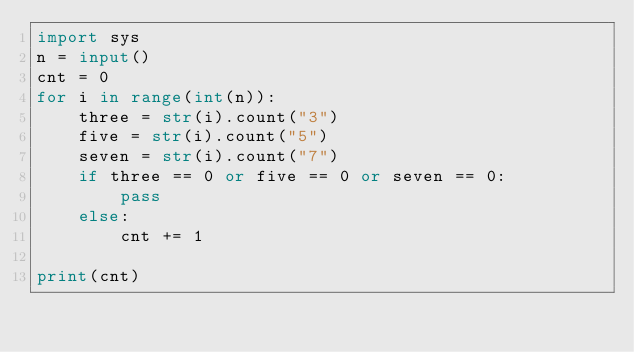<code> <loc_0><loc_0><loc_500><loc_500><_Python_>import sys
n = input()
cnt = 0
for i in range(int(n)):
    three = str(i).count("3")
    five = str(i).count("5")
    seven = str(i).count("7")
    if three == 0 or five == 0 or seven == 0:
        pass
    else:
        cnt += 1

print(cnt)</code> 